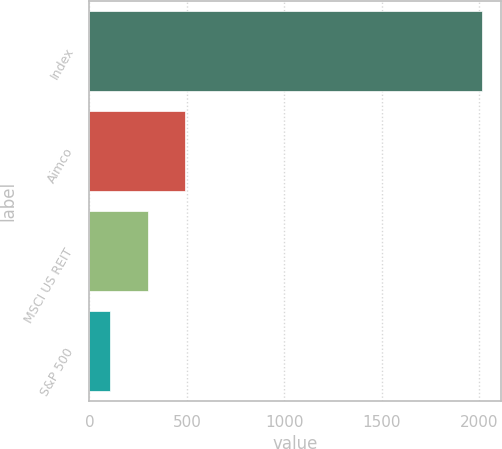Convert chart to OTSL. <chart><loc_0><loc_0><loc_500><loc_500><bar_chart><fcel>Index<fcel>Aimco<fcel>MSCI US REIT<fcel>S&P 500<nl><fcel>2012<fcel>489.27<fcel>298.93<fcel>108.59<nl></chart> 